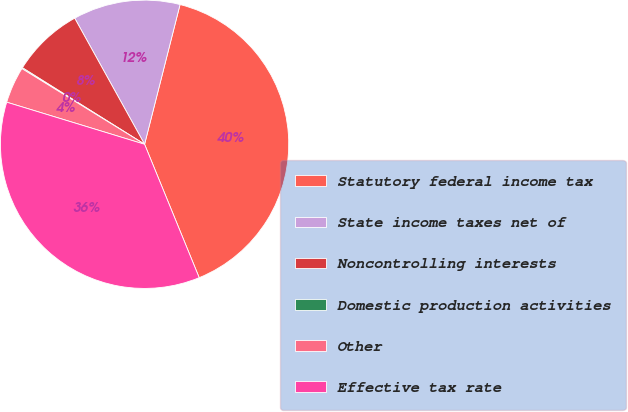Convert chart. <chart><loc_0><loc_0><loc_500><loc_500><pie_chart><fcel>Statutory federal income tax<fcel>State income taxes net of<fcel>Noncontrolling interests<fcel>Domestic production activities<fcel>Other<fcel>Effective tax rate<nl><fcel>39.86%<fcel>12.01%<fcel>8.04%<fcel>0.11%<fcel>4.08%<fcel>35.9%<nl></chart> 